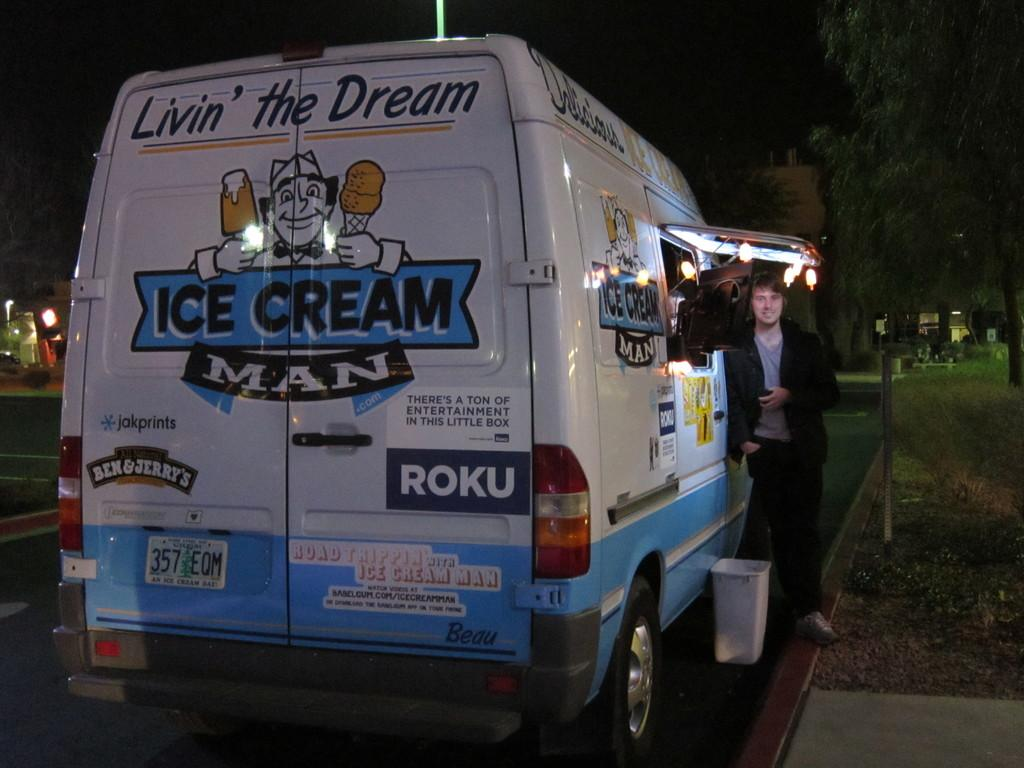<image>
Offer a succinct explanation of the picture presented. Man standing next to a blue and white van on which the words "Livin' the Dream" and "Ice Cream Man" are displayed. 